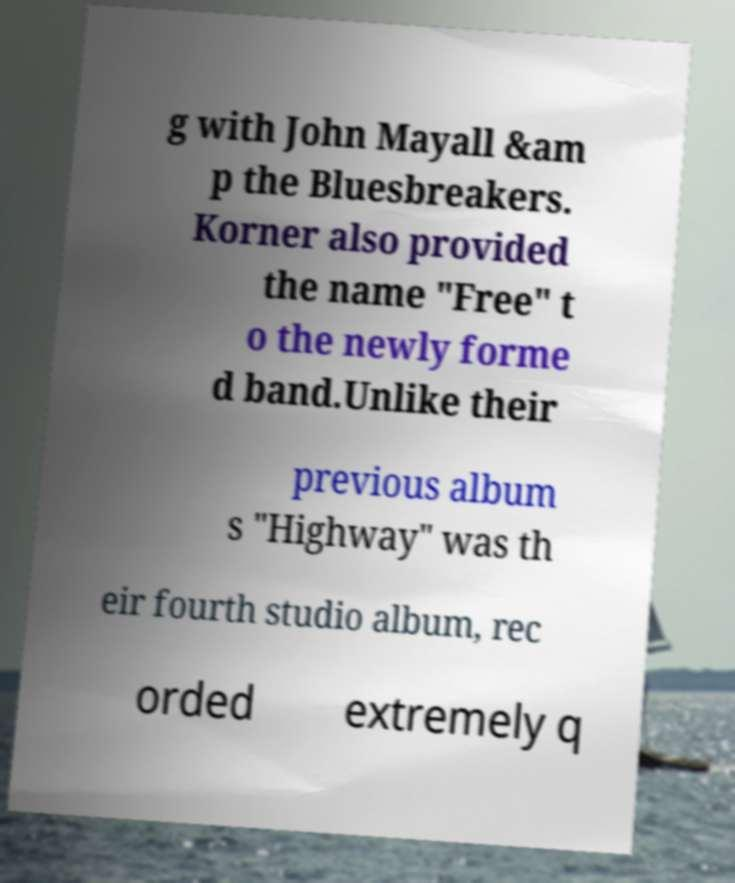Could you assist in decoding the text presented in this image and type it out clearly? g with John Mayall &am p the Bluesbreakers. Korner also provided the name "Free" t o the newly forme d band.Unlike their previous album s "Highway" was th eir fourth studio album, rec orded extremely q 